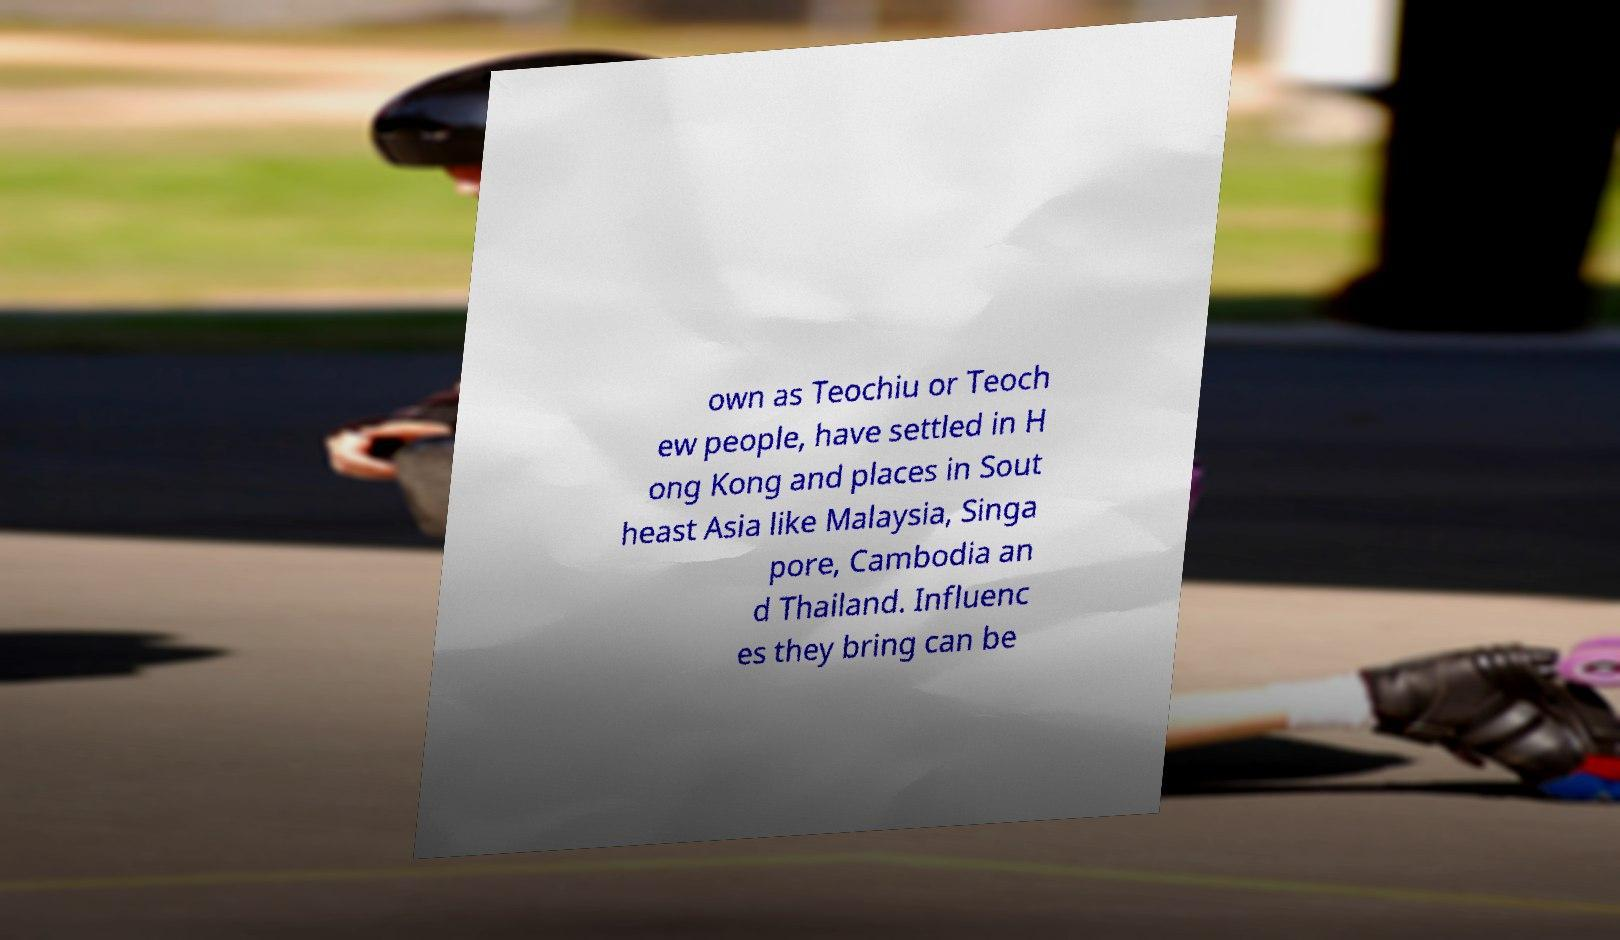For documentation purposes, I need the text within this image transcribed. Could you provide that? own as Teochiu or Teoch ew people, have settled in H ong Kong and places in Sout heast Asia like Malaysia, Singa pore, Cambodia an d Thailand. Influenc es they bring can be 